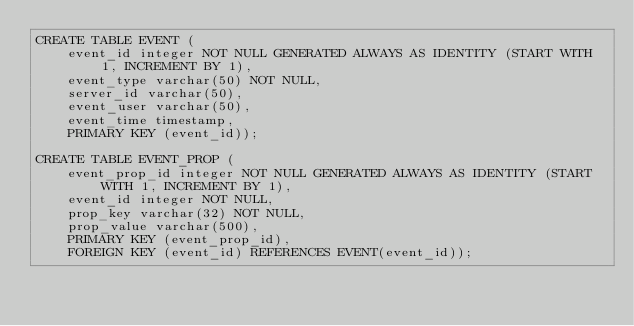Convert code to text. <code><loc_0><loc_0><loc_500><loc_500><_SQL_>CREATE TABLE EVENT (
    event_id integer NOT NULL GENERATED ALWAYS AS IDENTITY (START WITH 1, INCREMENT BY 1),
    event_type varchar(50) NOT NULL,
    server_id varchar(50),
    event_user varchar(50),
    event_time timestamp,
    PRIMARY KEY (event_id));

CREATE TABLE EVENT_PROP (
    event_prop_id integer NOT NULL GENERATED ALWAYS AS IDENTITY (START WITH 1, INCREMENT BY 1),
    event_id integer NOT NULL,
    prop_key varchar(32) NOT NULL,
    prop_value varchar(500),
    PRIMARY KEY (event_prop_id),
    FOREIGN KEY (event_id) REFERENCES EVENT(event_id));
</code> 